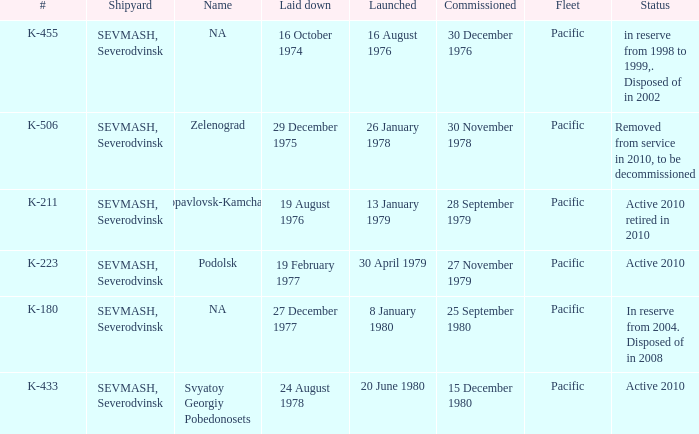Can you provide an update on the state of boat k-223? Active 2010. 